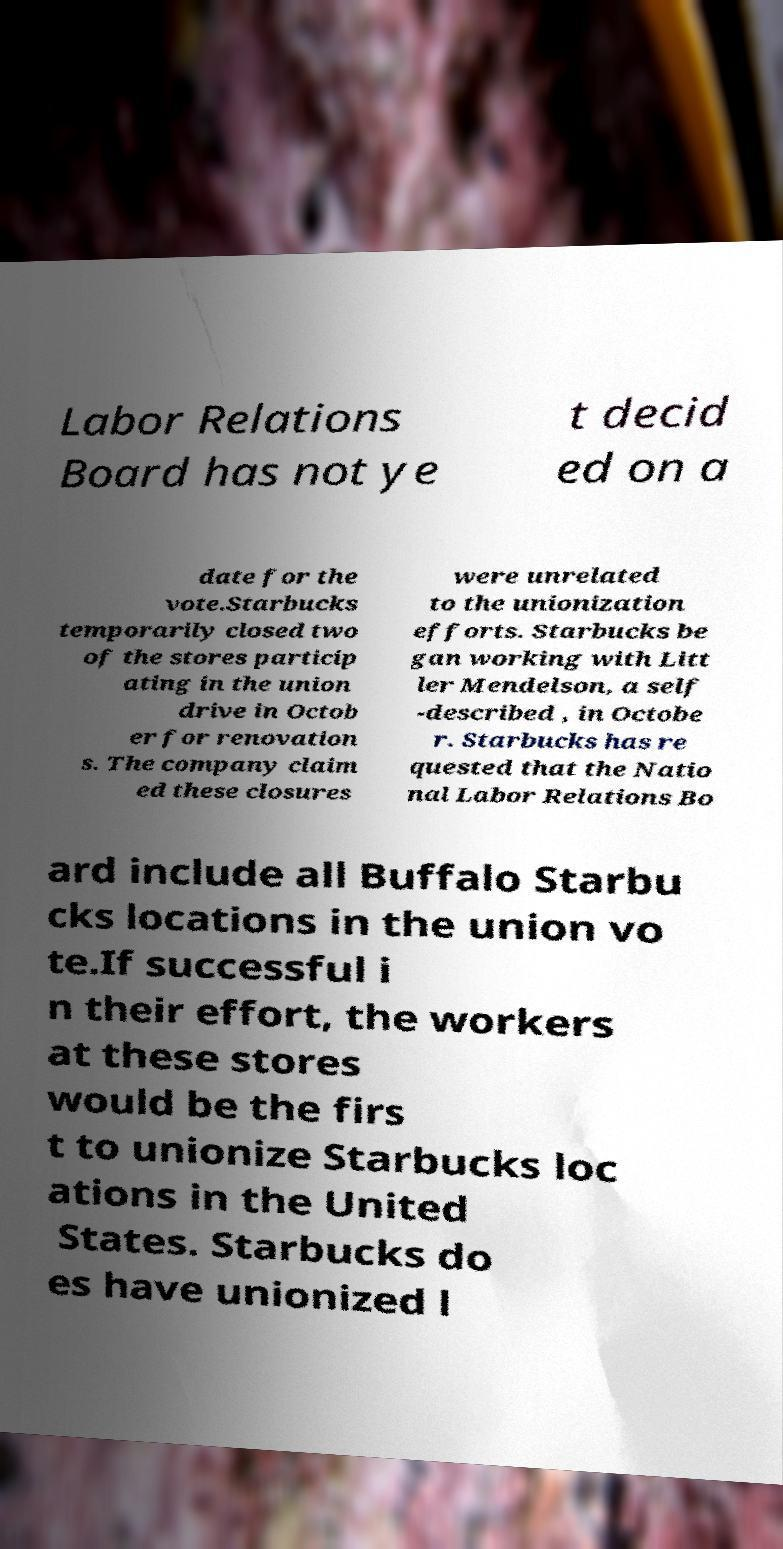There's text embedded in this image that I need extracted. Can you transcribe it verbatim? Labor Relations Board has not ye t decid ed on a date for the vote.Starbucks temporarily closed two of the stores particip ating in the union drive in Octob er for renovation s. The company claim ed these closures were unrelated to the unionization efforts. Starbucks be gan working with Litt ler Mendelson, a self -described , in Octobe r. Starbucks has re quested that the Natio nal Labor Relations Bo ard include all Buffalo Starbu cks locations in the union vo te.If successful i n their effort, the workers at these stores would be the firs t to unionize Starbucks loc ations in the United States. Starbucks do es have unionized l 